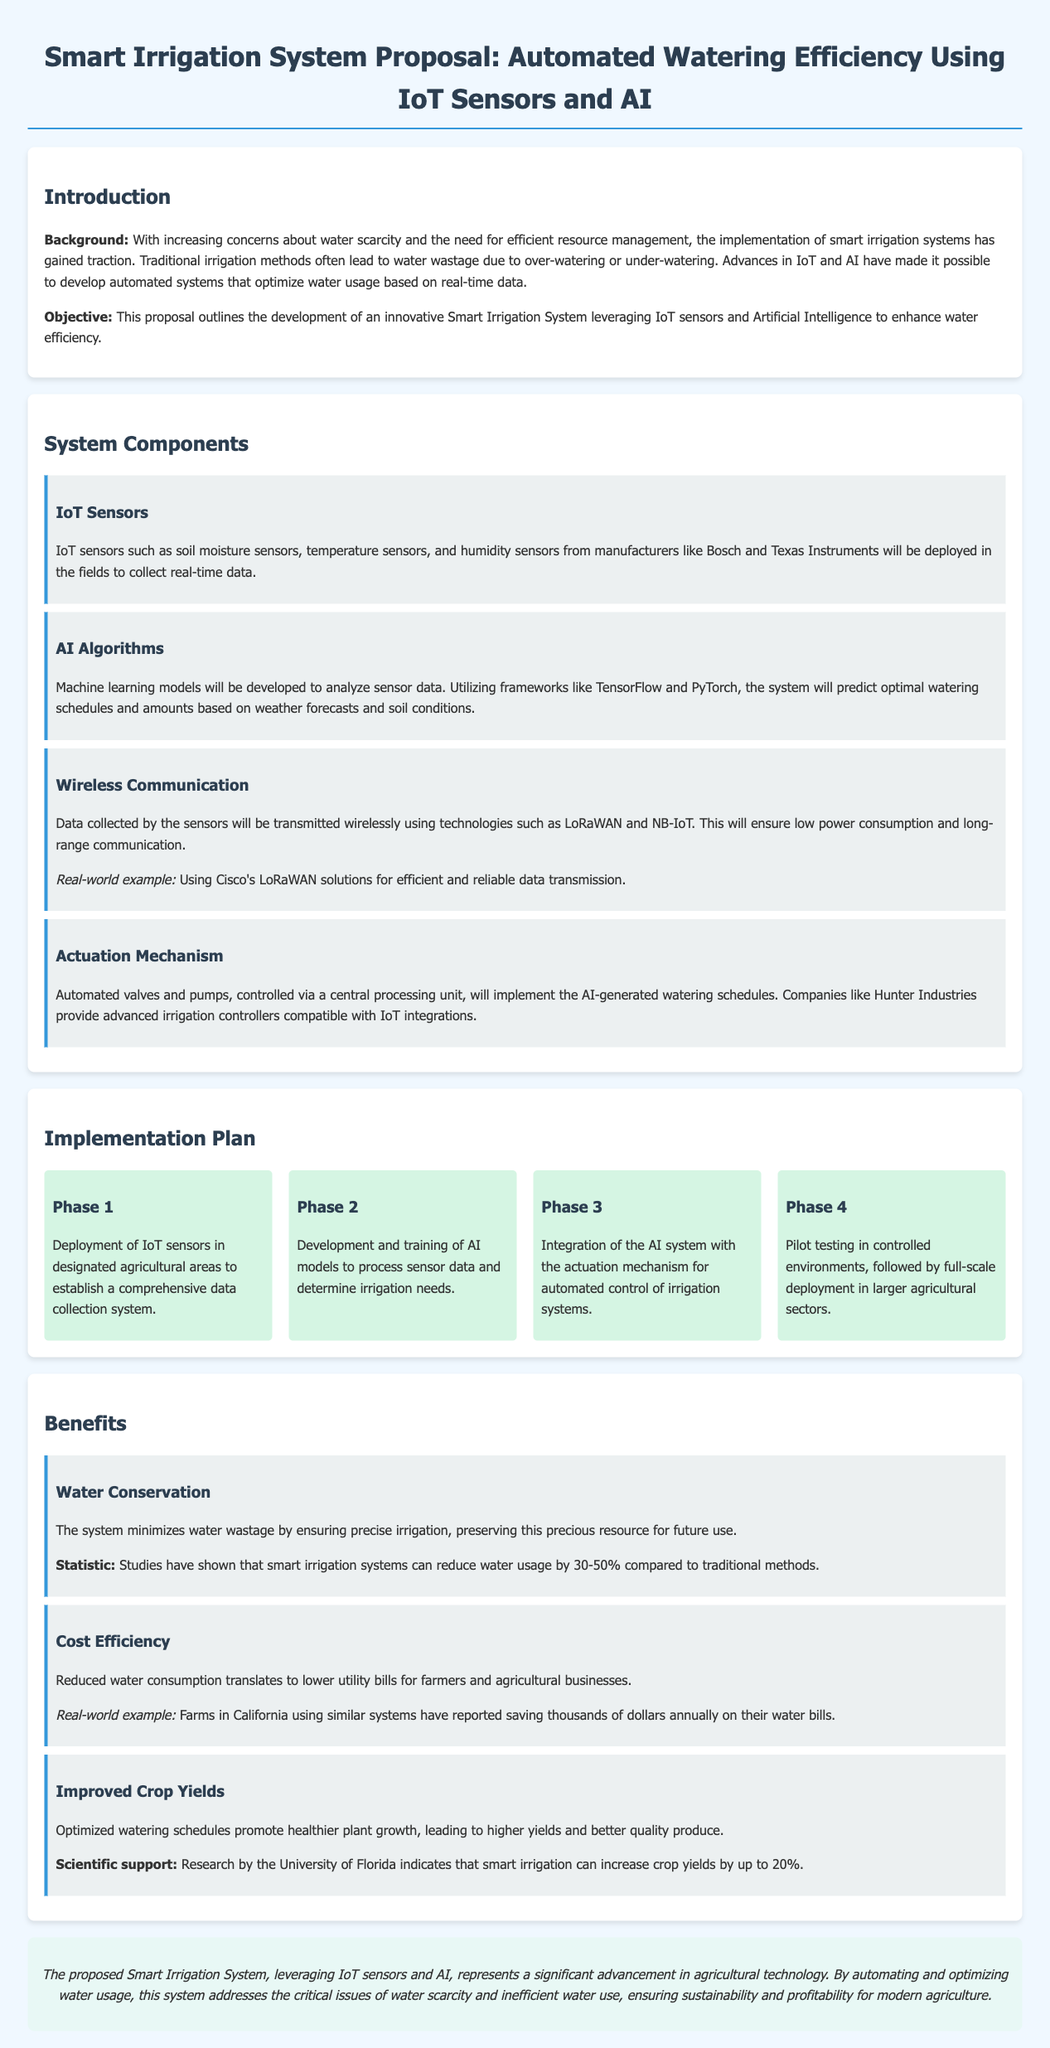What is the main objective of the proposal? The objective is to develop an innovative Smart Irrigation System leveraging IoT sensors and Artificial Intelligence to enhance water efficiency.
Answer: Enhance water efficiency Which technologies will be used for wireless communication? The document mentions LoRaWAN and NB-IoT as the technologies for wireless communication.
Answer: LoRaWAN and NB-IoT What is the expected reduction in water usage with smart irrigation systems? Studies cited in the document suggest that smart irrigation systems can reduce water usage by 30-50% compared to traditional methods.
Answer: 30-50% Name one manufacturer of IoT sensors mentioned in the proposal. The proposal mentions Bosch as a manufacturer of IoT sensors.
Answer: Bosch What phase involves pilot testing? Pilot testing is included in Phase 4 of the implementation plan.
Answer: Phase 4 How much can crop yields increase according to research by the University of Florida? The document states that smart irrigation can increase crop yields by up to 20%.
Answer: Up to 20% What component is responsible for analyzing sensor data? AI algorithms are responsible for analyzing sensor data as mentioned in the components section.
Answer: AI algorithms Which real-world example is provided for efficient data transmission? The proposal cites Cisco's LoRaWAN solutions as a real-world example for efficient data transmission.
Answer: Cisco's LoRaWAN solutions 